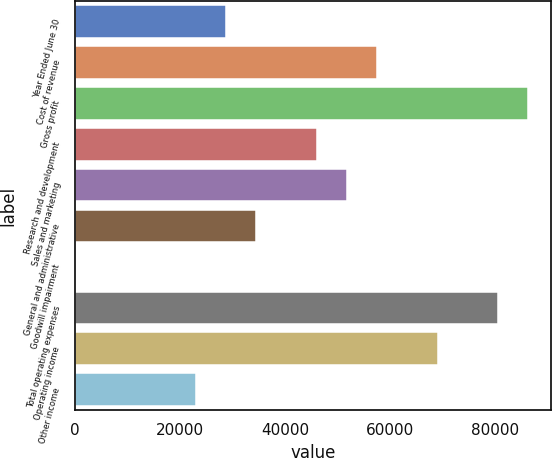Convert chart to OTSL. <chart><loc_0><loc_0><loc_500><loc_500><bar_chart><fcel>Year Ended June 30<fcel>Cost of revenue<fcel>Gross profit<fcel>Research and development<fcel>Sales and marketing<fcel>General and administrative<fcel>Goodwill impairment<fcel>Total operating expenses<fcel>Operating income<fcel>Other income<nl><fcel>28800.1<fcel>57600<fcel>86399.9<fcel>46080<fcel>51840<fcel>34560.1<fcel>0.19<fcel>80639.9<fcel>69119.9<fcel>23040.1<nl></chart> 